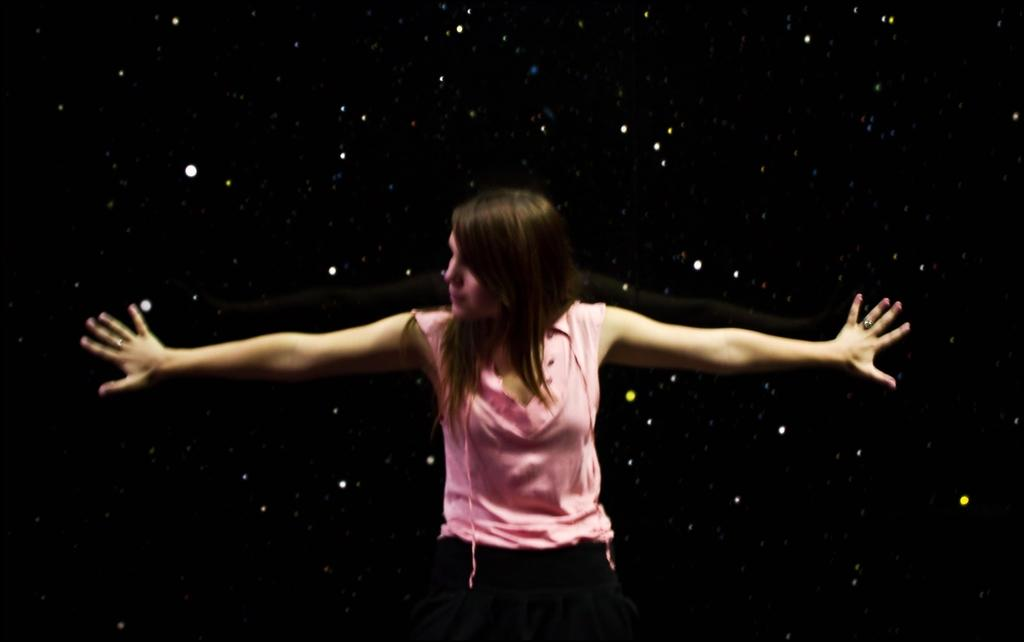What is the main subject of the image? The main subject of the image is a woman. What is the woman wearing in the image? The woman is wearing a pink dress in the image. What type of ink is the woman using to write on the pies in the image? There are no pies or ink present in the image; the woman is simply wearing a pink dress. 